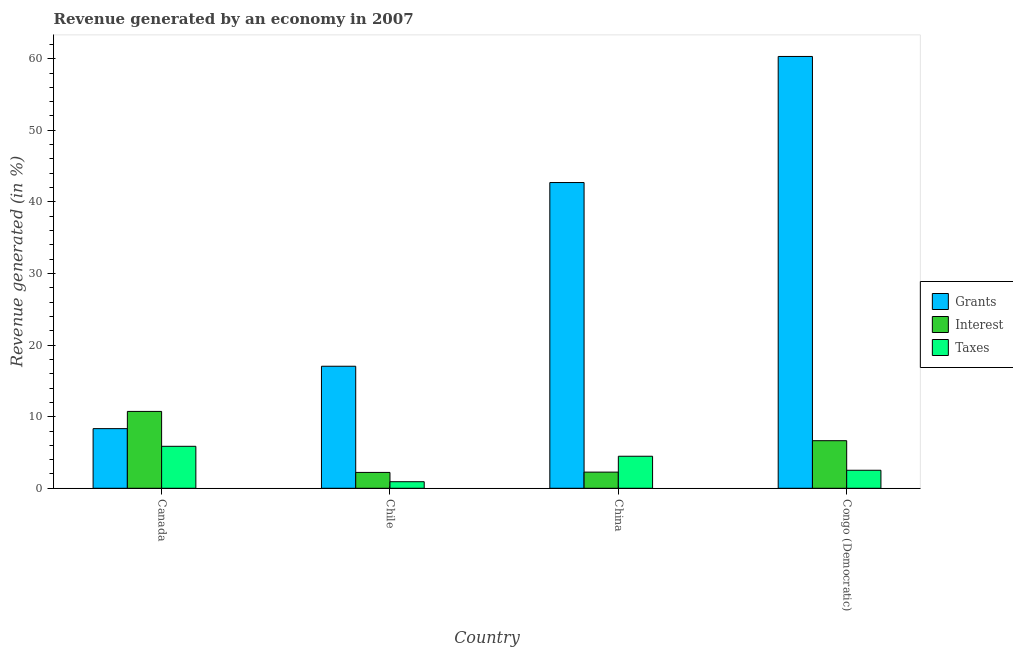How many different coloured bars are there?
Give a very brief answer. 3. How many bars are there on the 3rd tick from the left?
Keep it short and to the point. 3. How many bars are there on the 1st tick from the right?
Provide a short and direct response. 3. What is the percentage of revenue generated by grants in Chile?
Your response must be concise. 17.05. Across all countries, what is the maximum percentage of revenue generated by grants?
Make the answer very short. 60.31. Across all countries, what is the minimum percentage of revenue generated by grants?
Provide a short and direct response. 8.33. In which country was the percentage of revenue generated by grants maximum?
Offer a terse response. Congo (Democratic). In which country was the percentage of revenue generated by grants minimum?
Provide a succinct answer. Canada. What is the total percentage of revenue generated by grants in the graph?
Provide a short and direct response. 128.39. What is the difference between the percentage of revenue generated by taxes in Canada and that in Congo (Democratic)?
Offer a very short reply. 3.34. What is the difference between the percentage of revenue generated by taxes in China and the percentage of revenue generated by grants in Canada?
Your answer should be very brief. -3.86. What is the average percentage of revenue generated by taxes per country?
Your answer should be very brief. 3.44. What is the difference between the percentage of revenue generated by grants and percentage of revenue generated by taxes in China?
Provide a short and direct response. 38.23. In how many countries, is the percentage of revenue generated by interest greater than 36 %?
Keep it short and to the point. 0. What is the ratio of the percentage of revenue generated by interest in Chile to that in Congo (Democratic)?
Your response must be concise. 0.33. Is the percentage of revenue generated by taxes in Canada less than that in Congo (Democratic)?
Make the answer very short. No. Is the difference between the percentage of revenue generated by grants in China and Congo (Democratic) greater than the difference between the percentage of revenue generated by taxes in China and Congo (Democratic)?
Your response must be concise. No. What is the difference between the highest and the second highest percentage of revenue generated by taxes?
Your answer should be compact. 1.39. What is the difference between the highest and the lowest percentage of revenue generated by taxes?
Provide a short and direct response. 4.94. In how many countries, is the percentage of revenue generated by interest greater than the average percentage of revenue generated by interest taken over all countries?
Keep it short and to the point. 2. What does the 1st bar from the left in Canada represents?
Offer a very short reply. Grants. What does the 3rd bar from the right in Congo (Democratic) represents?
Keep it short and to the point. Grants. Is it the case that in every country, the sum of the percentage of revenue generated by grants and percentage of revenue generated by interest is greater than the percentage of revenue generated by taxes?
Offer a very short reply. Yes. How many bars are there?
Your response must be concise. 12. Does the graph contain any zero values?
Offer a terse response. No. Where does the legend appear in the graph?
Ensure brevity in your answer.  Center right. How many legend labels are there?
Your answer should be compact. 3. What is the title of the graph?
Offer a very short reply. Revenue generated by an economy in 2007. What is the label or title of the X-axis?
Ensure brevity in your answer.  Country. What is the label or title of the Y-axis?
Keep it short and to the point. Revenue generated (in %). What is the Revenue generated (in %) of Grants in Canada?
Your response must be concise. 8.33. What is the Revenue generated (in %) of Interest in Canada?
Your response must be concise. 10.74. What is the Revenue generated (in %) in Taxes in Canada?
Make the answer very short. 5.86. What is the Revenue generated (in %) of Grants in Chile?
Make the answer very short. 17.05. What is the Revenue generated (in %) of Interest in Chile?
Provide a succinct answer. 2.22. What is the Revenue generated (in %) in Taxes in Chile?
Give a very brief answer. 0.92. What is the Revenue generated (in %) in Grants in China?
Make the answer very short. 42.7. What is the Revenue generated (in %) of Interest in China?
Offer a very short reply. 2.26. What is the Revenue generated (in %) in Taxes in China?
Your answer should be very brief. 4.47. What is the Revenue generated (in %) of Grants in Congo (Democratic)?
Your answer should be very brief. 60.31. What is the Revenue generated (in %) in Interest in Congo (Democratic)?
Provide a succinct answer. 6.65. What is the Revenue generated (in %) in Taxes in Congo (Democratic)?
Keep it short and to the point. 2.52. Across all countries, what is the maximum Revenue generated (in %) in Grants?
Ensure brevity in your answer.  60.31. Across all countries, what is the maximum Revenue generated (in %) of Interest?
Your answer should be very brief. 10.74. Across all countries, what is the maximum Revenue generated (in %) of Taxes?
Offer a very short reply. 5.86. Across all countries, what is the minimum Revenue generated (in %) of Grants?
Your answer should be compact. 8.33. Across all countries, what is the minimum Revenue generated (in %) of Interest?
Your answer should be compact. 2.22. Across all countries, what is the minimum Revenue generated (in %) of Taxes?
Provide a succinct answer. 0.92. What is the total Revenue generated (in %) in Grants in the graph?
Offer a very short reply. 128.39. What is the total Revenue generated (in %) in Interest in the graph?
Offer a very short reply. 21.86. What is the total Revenue generated (in %) in Taxes in the graph?
Provide a short and direct response. 13.77. What is the difference between the Revenue generated (in %) of Grants in Canada and that in Chile?
Provide a short and direct response. -8.71. What is the difference between the Revenue generated (in %) in Interest in Canada and that in Chile?
Your answer should be compact. 8.52. What is the difference between the Revenue generated (in %) of Taxes in Canada and that in Chile?
Provide a short and direct response. 4.94. What is the difference between the Revenue generated (in %) of Grants in Canada and that in China?
Offer a terse response. -34.37. What is the difference between the Revenue generated (in %) in Interest in Canada and that in China?
Provide a succinct answer. 8.48. What is the difference between the Revenue generated (in %) of Taxes in Canada and that in China?
Make the answer very short. 1.39. What is the difference between the Revenue generated (in %) of Grants in Canada and that in Congo (Democratic)?
Offer a very short reply. -51.98. What is the difference between the Revenue generated (in %) of Interest in Canada and that in Congo (Democratic)?
Provide a short and direct response. 4.09. What is the difference between the Revenue generated (in %) of Taxes in Canada and that in Congo (Democratic)?
Make the answer very short. 3.34. What is the difference between the Revenue generated (in %) in Grants in Chile and that in China?
Ensure brevity in your answer.  -25.66. What is the difference between the Revenue generated (in %) in Interest in Chile and that in China?
Give a very brief answer. -0.04. What is the difference between the Revenue generated (in %) of Taxes in Chile and that in China?
Provide a succinct answer. -3.56. What is the difference between the Revenue generated (in %) of Grants in Chile and that in Congo (Democratic)?
Your answer should be compact. -43.27. What is the difference between the Revenue generated (in %) of Interest in Chile and that in Congo (Democratic)?
Your answer should be very brief. -4.43. What is the difference between the Revenue generated (in %) in Taxes in Chile and that in Congo (Democratic)?
Provide a succinct answer. -1.6. What is the difference between the Revenue generated (in %) of Grants in China and that in Congo (Democratic)?
Make the answer very short. -17.61. What is the difference between the Revenue generated (in %) in Interest in China and that in Congo (Democratic)?
Keep it short and to the point. -4.39. What is the difference between the Revenue generated (in %) in Taxes in China and that in Congo (Democratic)?
Make the answer very short. 1.96. What is the difference between the Revenue generated (in %) in Grants in Canada and the Revenue generated (in %) in Interest in Chile?
Make the answer very short. 6.12. What is the difference between the Revenue generated (in %) in Grants in Canada and the Revenue generated (in %) in Taxes in Chile?
Provide a succinct answer. 7.41. What is the difference between the Revenue generated (in %) in Interest in Canada and the Revenue generated (in %) in Taxes in Chile?
Keep it short and to the point. 9.82. What is the difference between the Revenue generated (in %) of Grants in Canada and the Revenue generated (in %) of Interest in China?
Offer a terse response. 6.07. What is the difference between the Revenue generated (in %) in Grants in Canada and the Revenue generated (in %) in Taxes in China?
Your answer should be very brief. 3.86. What is the difference between the Revenue generated (in %) in Interest in Canada and the Revenue generated (in %) in Taxes in China?
Ensure brevity in your answer.  6.26. What is the difference between the Revenue generated (in %) of Grants in Canada and the Revenue generated (in %) of Interest in Congo (Democratic)?
Keep it short and to the point. 1.68. What is the difference between the Revenue generated (in %) in Grants in Canada and the Revenue generated (in %) in Taxes in Congo (Democratic)?
Offer a terse response. 5.81. What is the difference between the Revenue generated (in %) of Interest in Canada and the Revenue generated (in %) of Taxes in Congo (Democratic)?
Your response must be concise. 8.22. What is the difference between the Revenue generated (in %) in Grants in Chile and the Revenue generated (in %) in Interest in China?
Keep it short and to the point. 14.79. What is the difference between the Revenue generated (in %) in Grants in Chile and the Revenue generated (in %) in Taxes in China?
Offer a terse response. 12.57. What is the difference between the Revenue generated (in %) of Interest in Chile and the Revenue generated (in %) of Taxes in China?
Your answer should be very brief. -2.26. What is the difference between the Revenue generated (in %) of Grants in Chile and the Revenue generated (in %) of Interest in Congo (Democratic)?
Your answer should be very brief. 10.4. What is the difference between the Revenue generated (in %) in Grants in Chile and the Revenue generated (in %) in Taxes in Congo (Democratic)?
Your response must be concise. 14.53. What is the difference between the Revenue generated (in %) of Interest in Chile and the Revenue generated (in %) of Taxes in Congo (Democratic)?
Offer a very short reply. -0.3. What is the difference between the Revenue generated (in %) in Grants in China and the Revenue generated (in %) in Interest in Congo (Democratic)?
Provide a short and direct response. 36.06. What is the difference between the Revenue generated (in %) in Grants in China and the Revenue generated (in %) in Taxes in Congo (Democratic)?
Offer a very short reply. 40.19. What is the difference between the Revenue generated (in %) of Interest in China and the Revenue generated (in %) of Taxes in Congo (Democratic)?
Make the answer very short. -0.26. What is the average Revenue generated (in %) of Grants per country?
Your answer should be very brief. 32.1. What is the average Revenue generated (in %) of Interest per country?
Keep it short and to the point. 5.46. What is the average Revenue generated (in %) of Taxes per country?
Your response must be concise. 3.44. What is the difference between the Revenue generated (in %) of Grants and Revenue generated (in %) of Interest in Canada?
Your response must be concise. -2.41. What is the difference between the Revenue generated (in %) of Grants and Revenue generated (in %) of Taxes in Canada?
Make the answer very short. 2.47. What is the difference between the Revenue generated (in %) of Interest and Revenue generated (in %) of Taxes in Canada?
Keep it short and to the point. 4.87. What is the difference between the Revenue generated (in %) in Grants and Revenue generated (in %) in Interest in Chile?
Keep it short and to the point. 14.83. What is the difference between the Revenue generated (in %) of Grants and Revenue generated (in %) of Taxes in Chile?
Your response must be concise. 16.13. What is the difference between the Revenue generated (in %) in Interest and Revenue generated (in %) in Taxes in Chile?
Offer a very short reply. 1.3. What is the difference between the Revenue generated (in %) of Grants and Revenue generated (in %) of Interest in China?
Provide a succinct answer. 40.45. What is the difference between the Revenue generated (in %) of Grants and Revenue generated (in %) of Taxes in China?
Make the answer very short. 38.23. What is the difference between the Revenue generated (in %) in Interest and Revenue generated (in %) in Taxes in China?
Your answer should be very brief. -2.22. What is the difference between the Revenue generated (in %) of Grants and Revenue generated (in %) of Interest in Congo (Democratic)?
Make the answer very short. 53.67. What is the difference between the Revenue generated (in %) of Grants and Revenue generated (in %) of Taxes in Congo (Democratic)?
Provide a short and direct response. 57.79. What is the difference between the Revenue generated (in %) in Interest and Revenue generated (in %) in Taxes in Congo (Democratic)?
Ensure brevity in your answer.  4.13. What is the ratio of the Revenue generated (in %) of Grants in Canada to that in Chile?
Keep it short and to the point. 0.49. What is the ratio of the Revenue generated (in %) of Interest in Canada to that in Chile?
Your answer should be very brief. 4.85. What is the ratio of the Revenue generated (in %) of Taxes in Canada to that in Chile?
Give a very brief answer. 6.39. What is the ratio of the Revenue generated (in %) of Grants in Canada to that in China?
Your answer should be very brief. 0.2. What is the ratio of the Revenue generated (in %) in Interest in Canada to that in China?
Keep it short and to the point. 4.76. What is the ratio of the Revenue generated (in %) of Taxes in Canada to that in China?
Keep it short and to the point. 1.31. What is the ratio of the Revenue generated (in %) in Grants in Canada to that in Congo (Democratic)?
Ensure brevity in your answer.  0.14. What is the ratio of the Revenue generated (in %) in Interest in Canada to that in Congo (Democratic)?
Provide a short and direct response. 1.62. What is the ratio of the Revenue generated (in %) of Taxes in Canada to that in Congo (Democratic)?
Offer a very short reply. 2.33. What is the ratio of the Revenue generated (in %) of Grants in Chile to that in China?
Offer a very short reply. 0.4. What is the ratio of the Revenue generated (in %) of Interest in Chile to that in China?
Offer a very short reply. 0.98. What is the ratio of the Revenue generated (in %) of Taxes in Chile to that in China?
Your answer should be very brief. 0.2. What is the ratio of the Revenue generated (in %) of Grants in Chile to that in Congo (Democratic)?
Your response must be concise. 0.28. What is the ratio of the Revenue generated (in %) of Interest in Chile to that in Congo (Democratic)?
Your answer should be very brief. 0.33. What is the ratio of the Revenue generated (in %) in Taxes in Chile to that in Congo (Democratic)?
Offer a terse response. 0.36. What is the ratio of the Revenue generated (in %) in Grants in China to that in Congo (Democratic)?
Offer a very short reply. 0.71. What is the ratio of the Revenue generated (in %) in Interest in China to that in Congo (Democratic)?
Provide a succinct answer. 0.34. What is the ratio of the Revenue generated (in %) in Taxes in China to that in Congo (Democratic)?
Give a very brief answer. 1.78. What is the difference between the highest and the second highest Revenue generated (in %) in Grants?
Your answer should be compact. 17.61. What is the difference between the highest and the second highest Revenue generated (in %) in Interest?
Provide a succinct answer. 4.09. What is the difference between the highest and the second highest Revenue generated (in %) of Taxes?
Your response must be concise. 1.39. What is the difference between the highest and the lowest Revenue generated (in %) of Grants?
Your response must be concise. 51.98. What is the difference between the highest and the lowest Revenue generated (in %) of Interest?
Provide a short and direct response. 8.52. What is the difference between the highest and the lowest Revenue generated (in %) in Taxes?
Your answer should be very brief. 4.94. 